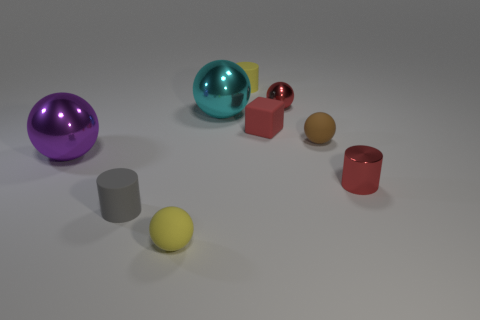Can you tell me the colors of the two spherical objects in the image? Sure, the two spherical objects are yellow and purple. 